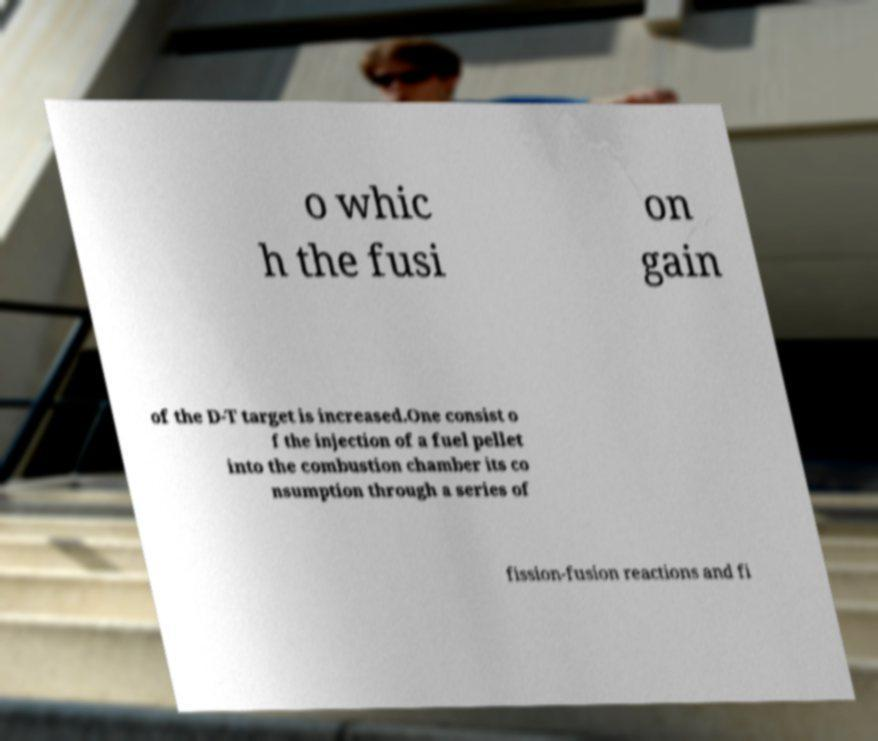I need the written content from this picture converted into text. Can you do that? o whic h the fusi on gain of the D-T target is increased.One consist o f the injection of a fuel pellet into the combustion chamber its co nsumption through a series of fission-fusion reactions and fi 